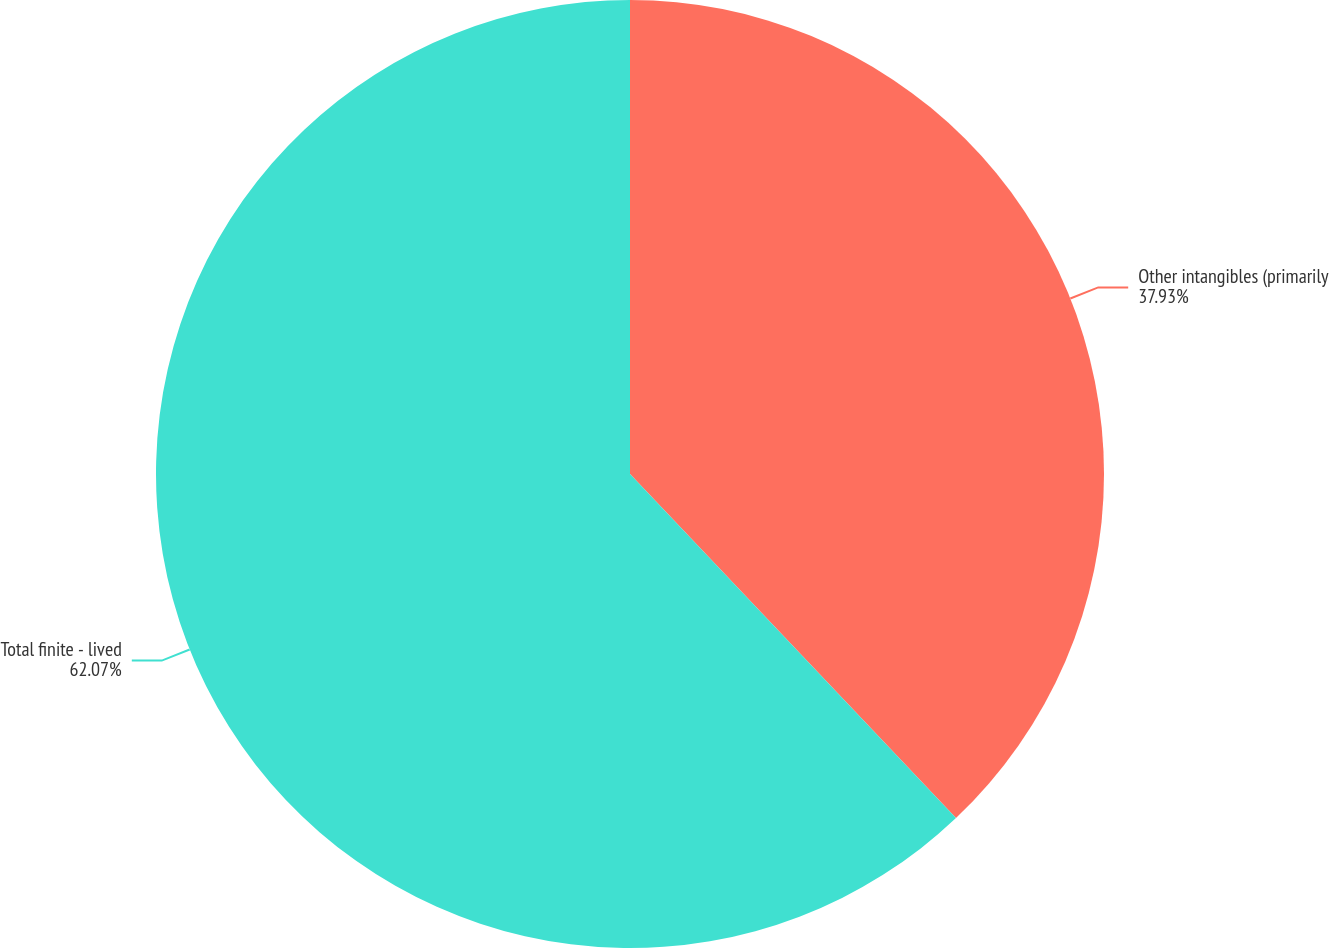<chart> <loc_0><loc_0><loc_500><loc_500><pie_chart><fcel>Other intangibles (primarily<fcel>Total finite - lived<nl><fcel>37.93%<fcel>62.07%<nl></chart> 